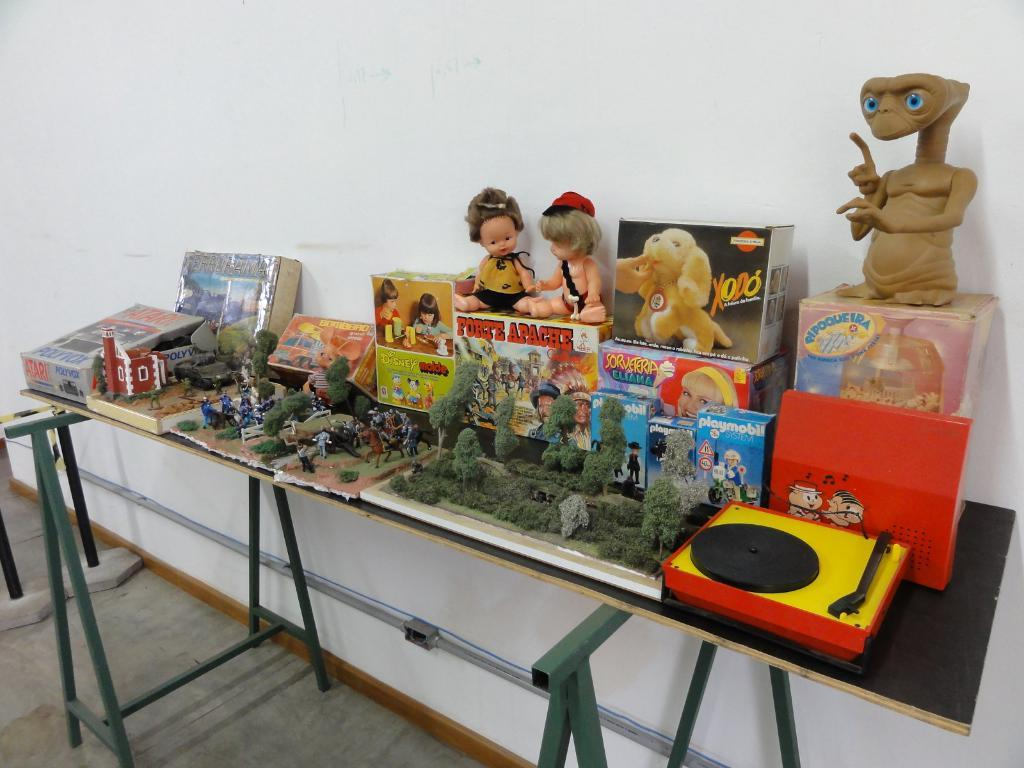<image>
Describe the image concisely. A table of different children's items, one being Disney molde. 